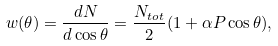<formula> <loc_0><loc_0><loc_500><loc_500>w ( \theta ) = \frac { d N } { d \cos { \theta } } = \frac { N _ { t o t } } { 2 } ( 1 + \alpha P \cos { \theta } ) ,</formula> 